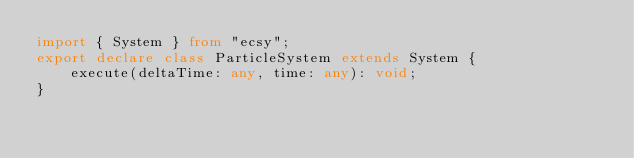Convert code to text. <code><loc_0><loc_0><loc_500><loc_500><_TypeScript_>import { System } from "ecsy";
export declare class ParticleSystem extends System {
    execute(deltaTime: any, time: any): void;
}
</code> 